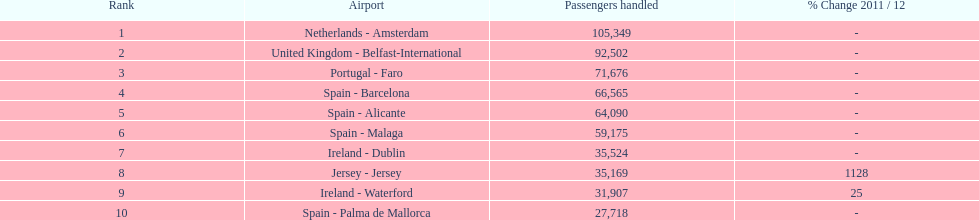Which airport facilities are in europe? Netherlands - Amsterdam, United Kingdom - Belfast-International, Portugal - Faro, Spain - Barcelona, Spain - Alicante, Spain - Malaga, Ireland - Dublin, Ireland - Waterford, Spain - Palma de Mallorca. Which one belongs to portugal? Portugal - Faro. Could you parse the entire table? {'header': ['Rank', 'Airport', 'Passengers handled', '% Change 2011 / 12'], 'rows': [['1', 'Netherlands - Amsterdam', '105,349', '-'], ['2', 'United Kingdom - Belfast-International', '92,502', '-'], ['3', 'Portugal - Faro', '71,676', '-'], ['4', 'Spain - Barcelona', '66,565', '-'], ['5', 'Spain - Alicante', '64,090', '-'], ['6', 'Spain - Malaga', '59,175', '-'], ['7', 'Ireland - Dublin', '35,524', '-'], ['8', 'Jersey - Jersey', '35,169', '1128'], ['9', 'Ireland - Waterford', '31,907', '25'], ['10', 'Spain - Palma de Mallorca', '27,718', '-']]} 